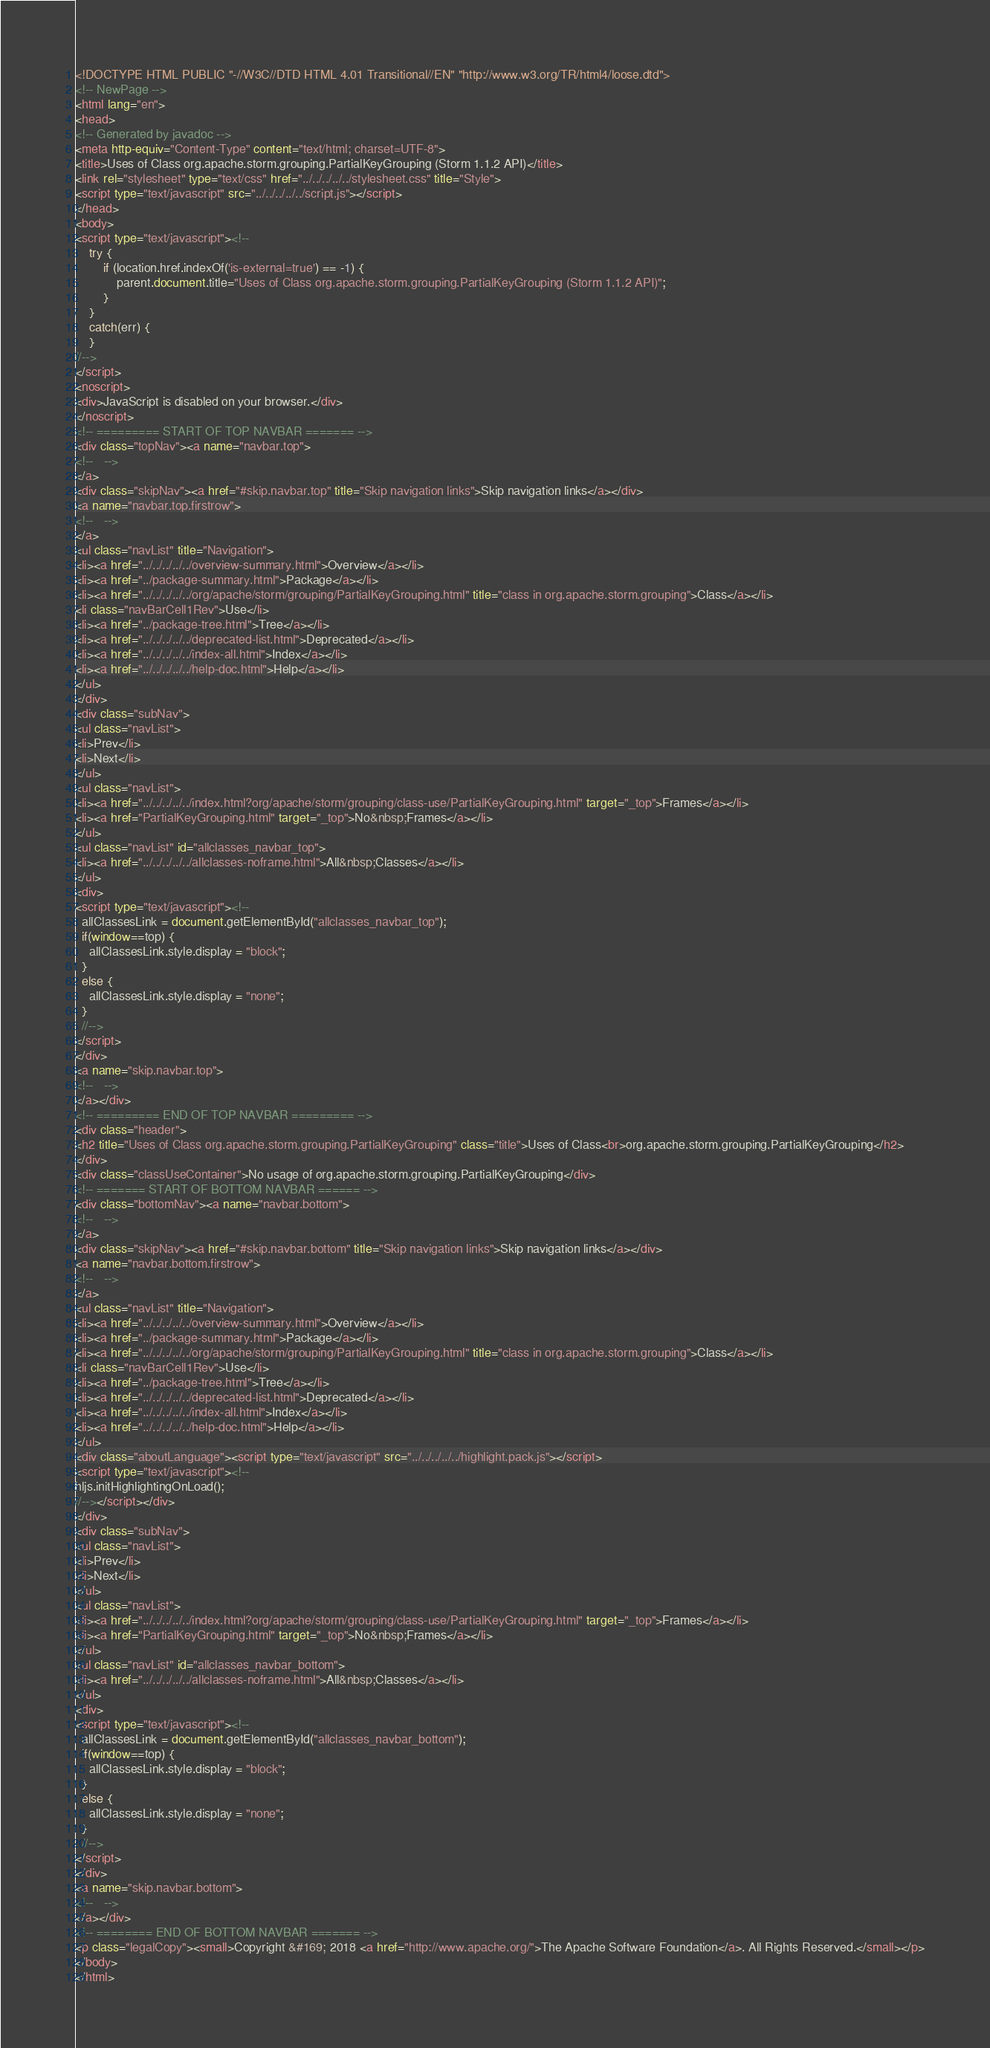Convert code to text. <code><loc_0><loc_0><loc_500><loc_500><_HTML_><!DOCTYPE HTML PUBLIC "-//W3C//DTD HTML 4.01 Transitional//EN" "http://www.w3.org/TR/html4/loose.dtd">
<!-- NewPage -->
<html lang="en">
<head>
<!-- Generated by javadoc -->
<meta http-equiv="Content-Type" content="text/html; charset=UTF-8">
<title>Uses of Class org.apache.storm.grouping.PartialKeyGrouping (Storm 1.1.2 API)</title>
<link rel="stylesheet" type="text/css" href="../../../../../stylesheet.css" title="Style">
<script type="text/javascript" src="../../../../../script.js"></script>
</head>
<body>
<script type="text/javascript"><!--
    try {
        if (location.href.indexOf('is-external=true') == -1) {
            parent.document.title="Uses of Class org.apache.storm.grouping.PartialKeyGrouping (Storm 1.1.2 API)";
        }
    }
    catch(err) {
    }
//-->
</script>
<noscript>
<div>JavaScript is disabled on your browser.</div>
</noscript>
<!-- ========= START OF TOP NAVBAR ======= -->
<div class="topNav"><a name="navbar.top">
<!--   -->
</a>
<div class="skipNav"><a href="#skip.navbar.top" title="Skip navigation links">Skip navigation links</a></div>
<a name="navbar.top.firstrow">
<!--   -->
</a>
<ul class="navList" title="Navigation">
<li><a href="../../../../../overview-summary.html">Overview</a></li>
<li><a href="../package-summary.html">Package</a></li>
<li><a href="../../../../../org/apache/storm/grouping/PartialKeyGrouping.html" title="class in org.apache.storm.grouping">Class</a></li>
<li class="navBarCell1Rev">Use</li>
<li><a href="../package-tree.html">Tree</a></li>
<li><a href="../../../../../deprecated-list.html">Deprecated</a></li>
<li><a href="../../../../../index-all.html">Index</a></li>
<li><a href="../../../../../help-doc.html">Help</a></li>
</ul>
</div>
<div class="subNav">
<ul class="navList">
<li>Prev</li>
<li>Next</li>
</ul>
<ul class="navList">
<li><a href="../../../../../index.html?org/apache/storm/grouping/class-use/PartialKeyGrouping.html" target="_top">Frames</a></li>
<li><a href="PartialKeyGrouping.html" target="_top">No&nbsp;Frames</a></li>
</ul>
<ul class="navList" id="allclasses_navbar_top">
<li><a href="../../../../../allclasses-noframe.html">All&nbsp;Classes</a></li>
</ul>
<div>
<script type="text/javascript"><!--
  allClassesLink = document.getElementById("allclasses_navbar_top");
  if(window==top) {
    allClassesLink.style.display = "block";
  }
  else {
    allClassesLink.style.display = "none";
  }
  //-->
</script>
</div>
<a name="skip.navbar.top">
<!--   -->
</a></div>
<!-- ========= END OF TOP NAVBAR ========= -->
<div class="header">
<h2 title="Uses of Class org.apache.storm.grouping.PartialKeyGrouping" class="title">Uses of Class<br>org.apache.storm.grouping.PartialKeyGrouping</h2>
</div>
<div class="classUseContainer">No usage of org.apache.storm.grouping.PartialKeyGrouping</div>
<!-- ======= START OF BOTTOM NAVBAR ====== -->
<div class="bottomNav"><a name="navbar.bottom">
<!--   -->
</a>
<div class="skipNav"><a href="#skip.navbar.bottom" title="Skip navigation links">Skip navigation links</a></div>
<a name="navbar.bottom.firstrow">
<!--   -->
</a>
<ul class="navList" title="Navigation">
<li><a href="../../../../../overview-summary.html">Overview</a></li>
<li><a href="../package-summary.html">Package</a></li>
<li><a href="../../../../../org/apache/storm/grouping/PartialKeyGrouping.html" title="class in org.apache.storm.grouping">Class</a></li>
<li class="navBarCell1Rev">Use</li>
<li><a href="../package-tree.html">Tree</a></li>
<li><a href="../../../../../deprecated-list.html">Deprecated</a></li>
<li><a href="../../../../../index-all.html">Index</a></li>
<li><a href="../../../../../help-doc.html">Help</a></li>
</ul>
<div class="aboutLanguage"><script type="text/javascript" src="../../../../../highlight.pack.js"></script>
<script type="text/javascript"><!--
hljs.initHighlightingOnLoad();
//--></script></div>
</div>
<div class="subNav">
<ul class="navList">
<li>Prev</li>
<li>Next</li>
</ul>
<ul class="navList">
<li><a href="../../../../../index.html?org/apache/storm/grouping/class-use/PartialKeyGrouping.html" target="_top">Frames</a></li>
<li><a href="PartialKeyGrouping.html" target="_top">No&nbsp;Frames</a></li>
</ul>
<ul class="navList" id="allclasses_navbar_bottom">
<li><a href="../../../../../allclasses-noframe.html">All&nbsp;Classes</a></li>
</ul>
<div>
<script type="text/javascript"><!--
  allClassesLink = document.getElementById("allclasses_navbar_bottom");
  if(window==top) {
    allClassesLink.style.display = "block";
  }
  else {
    allClassesLink.style.display = "none";
  }
  //-->
</script>
</div>
<a name="skip.navbar.bottom">
<!--   -->
</a></div>
<!-- ======== END OF BOTTOM NAVBAR ======= -->
<p class="legalCopy"><small>Copyright &#169; 2018 <a href="http://www.apache.org/">The Apache Software Foundation</a>. All Rights Reserved.</small></p>
</body>
</html>
</code> 